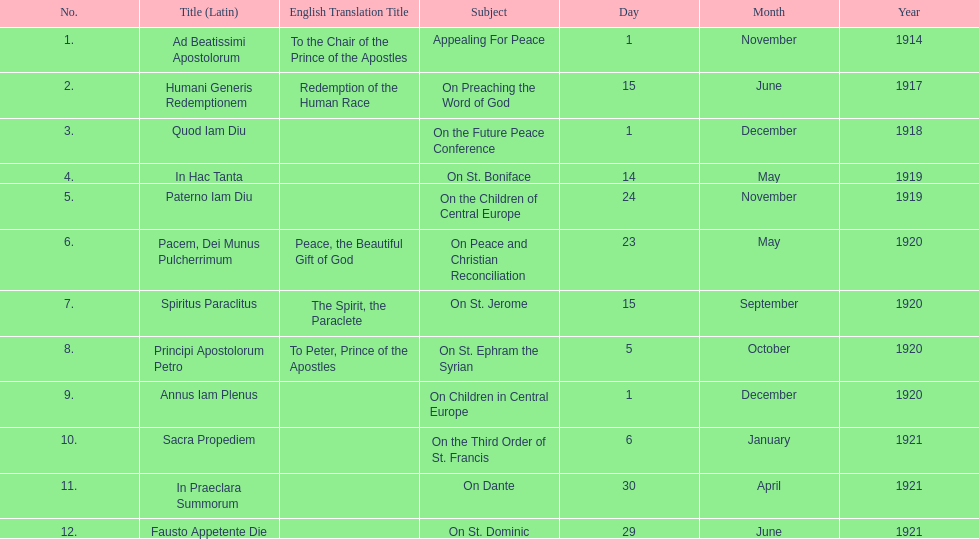What is the only subject on 23 may 1920? On Peace and Christian Reconciliation. 